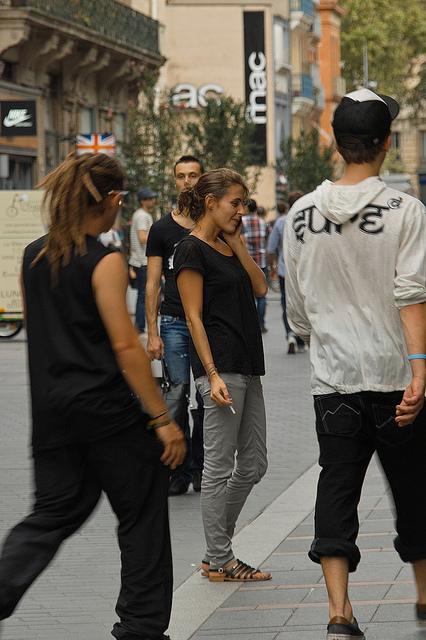What type of hats are the men wearing?
Give a very brief answer. Baseball cap. Could these men be on a team?
Answer briefly. No. What color are the mans shorts?
Quick response, please. Black. Are the people cold?
Be succinct. No. Is the woman carrying a childs object?
Write a very short answer. No. What color shirt is the girl wearing?
Short answer required. Black. What are they walking across?
Quick response, please. Street. What color is the man's bracelet?
Give a very brief answer. Blue. What color are the lady's pants?
Quick response, please. Gray. Are they likely in an organization?
Write a very short answer. No. What flag can be seen in the picture?
Keep it brief. British. What color pants is she wearing?
Give a very brief answer. Gray. What color is her shirt?
Short answer required. Black. Is it raining?
Be succinct. No. Which person has dreads?
Answer briefly. Closest to camera. Where is the police car?
Concise answer only. Not here. How many people are shown?
Quick response, please. 5. Is everyone standing at the same level?
Be succinct. Yes. Where is the woman standing?
Be succinct. Sidewalk. What color is the ground?
Quick response, please. Gray. 